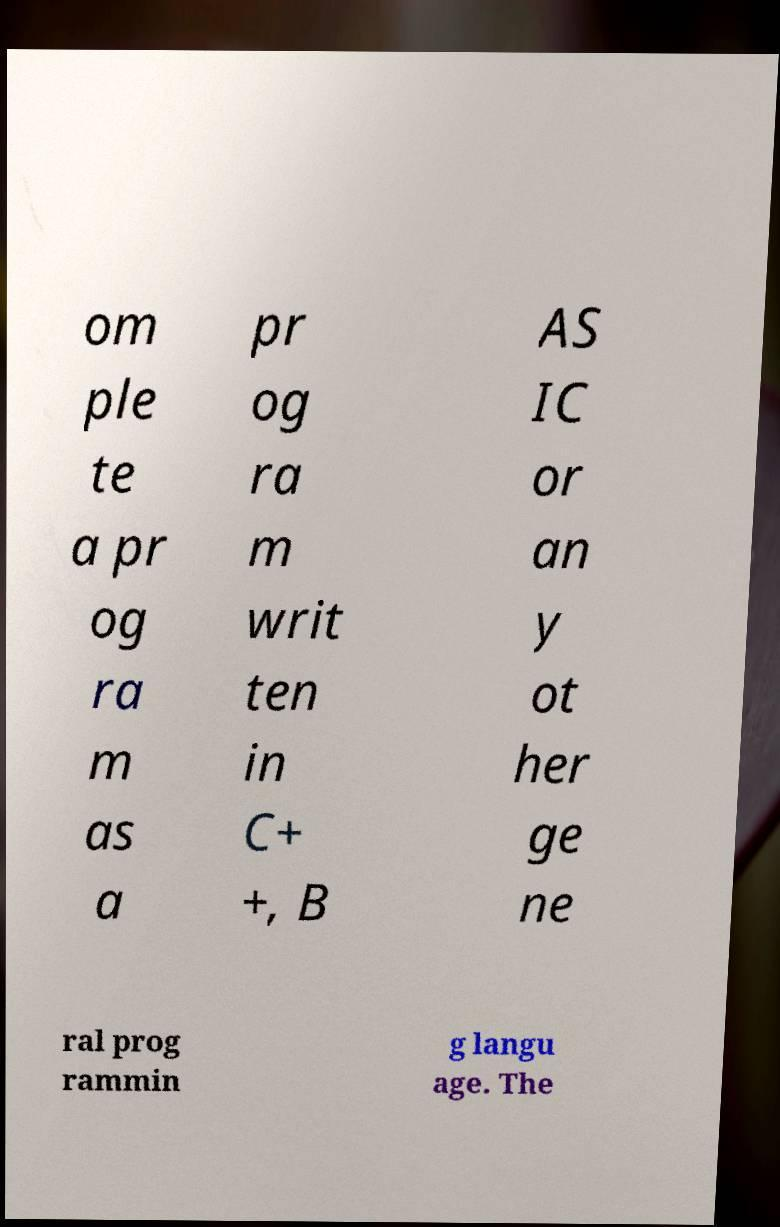Could you assist in decoding the text presented in this image and type it out clearly? om ple te a pr og ra m as a pr og ra m writ ten in C+ +, B AS IC or an y ot her ge ne ral prog rammin g langu age. The 